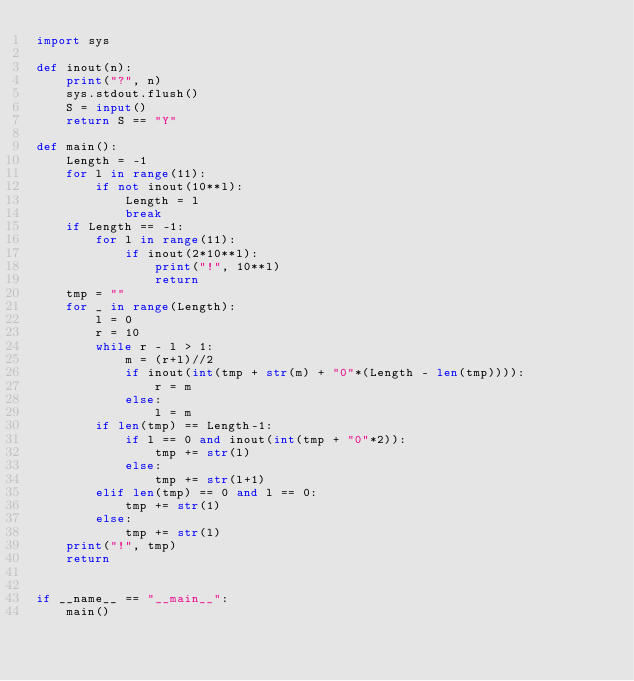<code> <loc_0><loc_0><loc_500><loc_500><_Python_>import sys

def inout(n):
    print("?", n)
    sys.stdout.flush()
    S = input()
    return S == "Y"

def main():
    Length = -1
    for l in range(11):
        if not inout(10**l):
            Length = l
            break
    if Length == -1:
        for l in range(11):
            if inout(2*10**l):
                print("!", 10**l)
                return
    tmp = ""
    for _ in range(Length):
        l = 0
        r = 10
        while r - l > 1:
            m = (r+l)//2
            if inout(int(tmp + str(m) + "0"*(Length - len(tmp)))):
                r = m
            else:
                l = m
        if len(tmp) == Length-1:
            if l == 0 and inout(int(tmp + "0"*2)):
                tmp += str(l)
            else:
                tmp += str(l+1)
        elif len(tmp) == 0 and l == 0:
            tmp += str(1)
        else:
            tmp += str(l)
    print("!", tmp)
    return


if __name__ == "__main__":
    main()</code> 